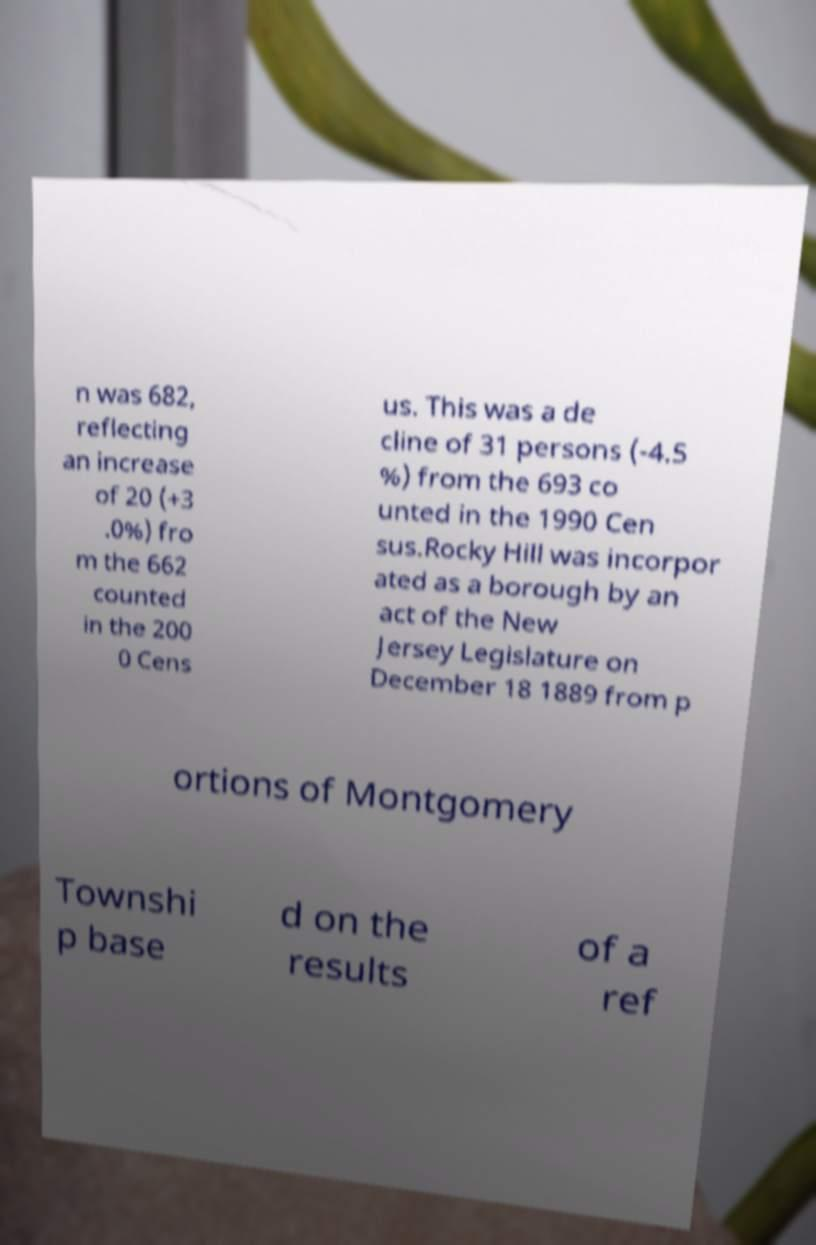I need the written content from this picture converted into text. Can you do that? n was 682, reflecting an increase of 20 (+3 .0%) fro m the 662 counted in the 200 0 Cens us. This was a de cline of 31 persons (-4.5 %) from the 693 co unted in the 1990 Cen sus.Rocky Hill was incorpor ated as a borough by an act of the New Jersey Legislature on December 18 1889 from p ortions of Montgomery Townshi p base d on the results of a ref 